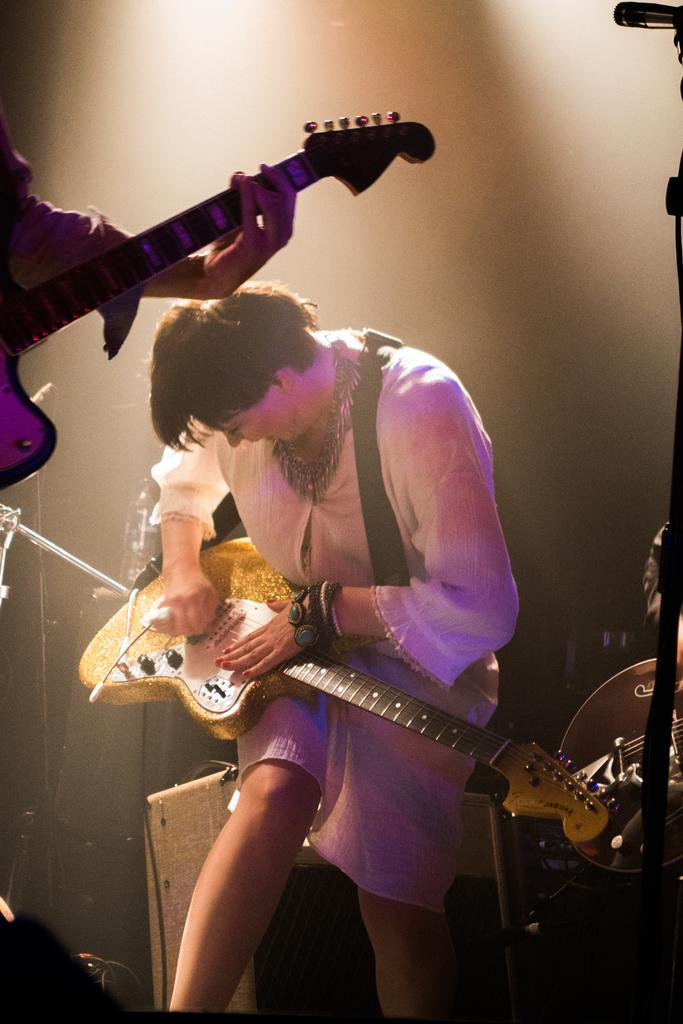What is the woman in the image doing? The woman is playing a guitar in the image. What is the woman wearing? The woman is wearing a white dress. What can be seen behind the woman? There is a box behind the woman. Who else is present in the image? There is another person in the image. What is the other person holding? The other person is holding a guitar. What type of thread is being used to create the fire in the image? There is no fire present in the image, and therefore no thread being used to create it. 